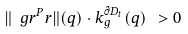<formula> <loc_0><loc_0><loc_500><loc_500>\| \ g r ^ { P } r \| ( q ) \cdot k _ { g } ^ { \partial D _ { t } } ( q ) \ > 0</formula> 